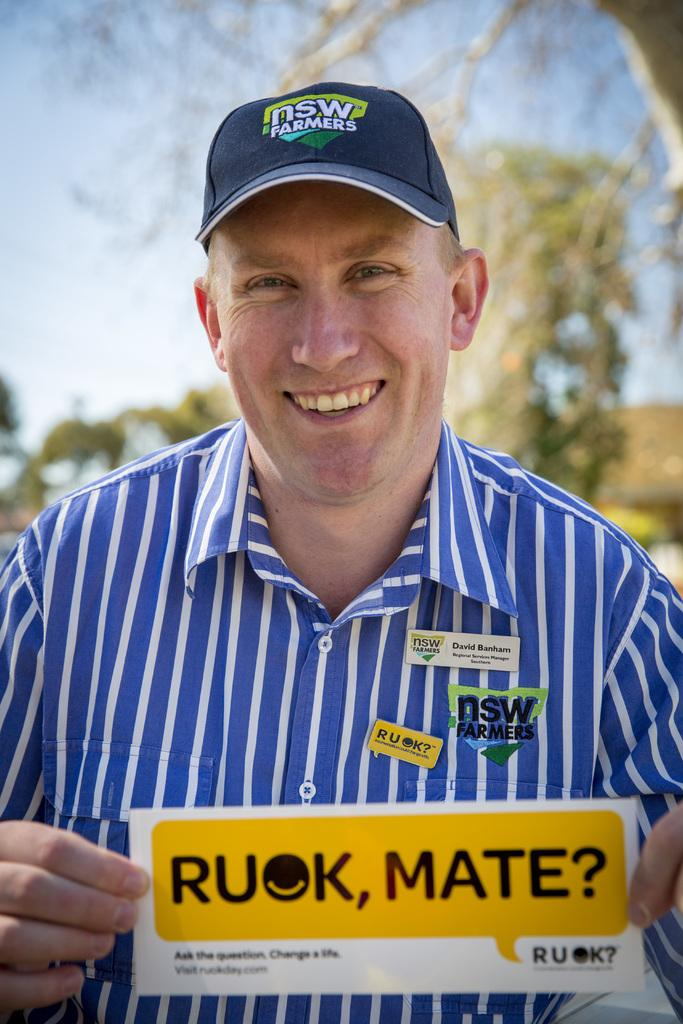<image>
Present a compact description of the photo's key features. A blue hat that has the words nsw farmers on it. 